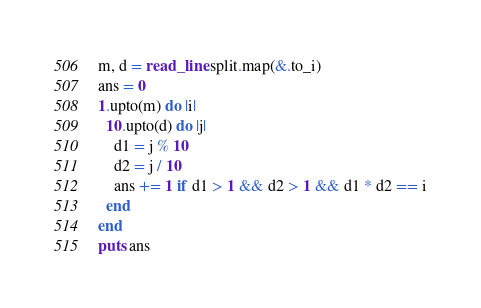Convert code to text. <code><loc_0><loc_0><loc_500><loc_500><_Crystal_>m, d = read_line.split.map(&.to_i)
ans = 0
1.upto(m) do |i|
  10.upto(d) do |j|
    d1 = j % 10
    d2 = j / 10
    ans += 1 if d1 > 1 && d2 > 1 && d1 * d2 == i
  end
end
puts ans
</code> 